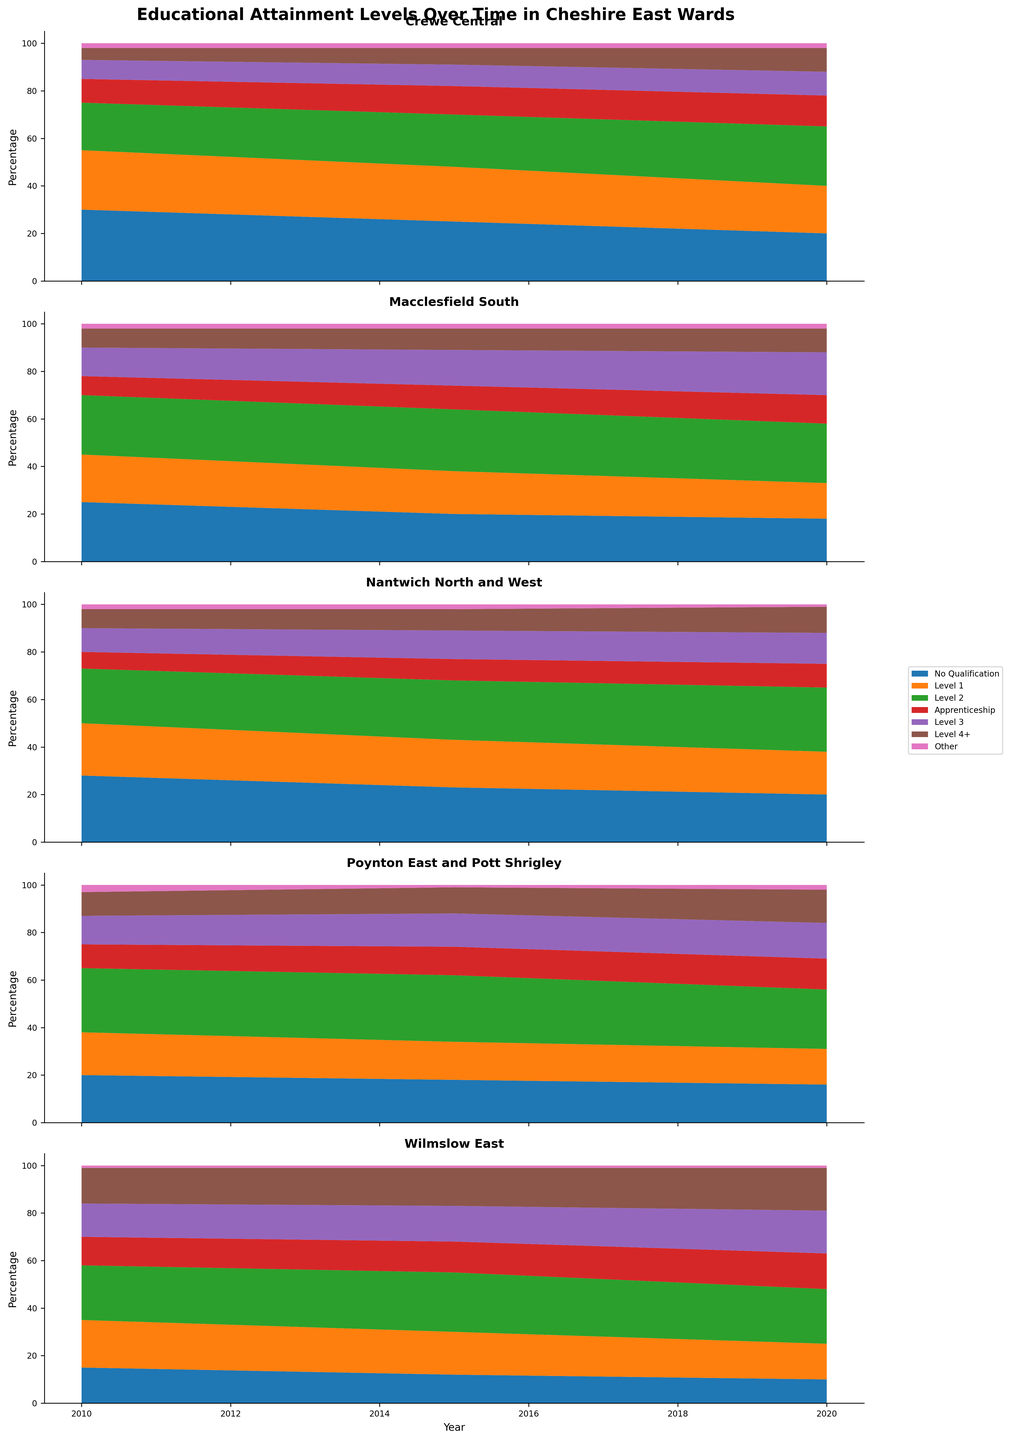What is the title of the figure? The title is located at the top center of the figure in bold font. It reads, "Educational Attainment Levels Over Time in Cheshire East Wards."
Answer: Educational Attainment Levels Over Time in Cheshire East Wards Which ward shows a noticeable increase in the percentage of people with Level 4+ qualifications from 2010 to 2020? By analyzing the stackplot for each ward, the Wilmslow East ward shows a significant increase, especially towards the end of the period.
Answer: Wilmslow East In Crewe Central, how has the percentage of residents with no qualifications changed from 2010 to 2020? In Crewe Central's stackplot, the segment for "No Qualification" in 2010 is at the top and has decreased in size by 2020. This indicates a decrease in the percentage of residents with no qualifications.
Answer: Decreased Which category had the smallest change in percentage over time in Poynton East and Pott Shrigley? Examining the stackplot for Poynton East and Pott Shrigley, the "Other" category appears to have a relatively stable thickness throughout the years, indicating the smallest change.
Answer: Other How do the apprenticeship levels in Nantwich North and West change from 2010 to 2020? The "Apprenticeship" category is represented by one of the segments in the stackplot. It shows a small increase in the percentage from 2010 to 2020.
Answer: Increased Which ward had the highest percentage of Level 2 qualifications in 2010 and how can you tell? By comparing the thickness of the "Level 2" segments across all wards in 2010, Poynton East and Pott Shrigley had the thickest segment, indicating the highest percentage.
Answer: Poynton East and Pott Shrigley In 2020, which ward has the smallest segment for 'No Qualification'? Observing the 2020 stackplots for the "No Qualification" category, Wilmslow East displays the smallest segment.
Answer: Wilmslow East Has the percentage of people with Level 1 qualifications decreased, increased, or remained stable in Macclesfield South from 2010 to 2020? Looking at the "Level 1" segment in the stackplot for Macclesfield South over the years, the thickness of the segment decreases, indicating a decrease in percentage.
Answer: Decreased In 2015, which educational attainment level had the highest percentage in Crewe Central? In the stackplot of Crewe Central for the year 2015, the "Level 2" segment is the thickest, indicating it has the highest percentage.
Answer: Level 2 